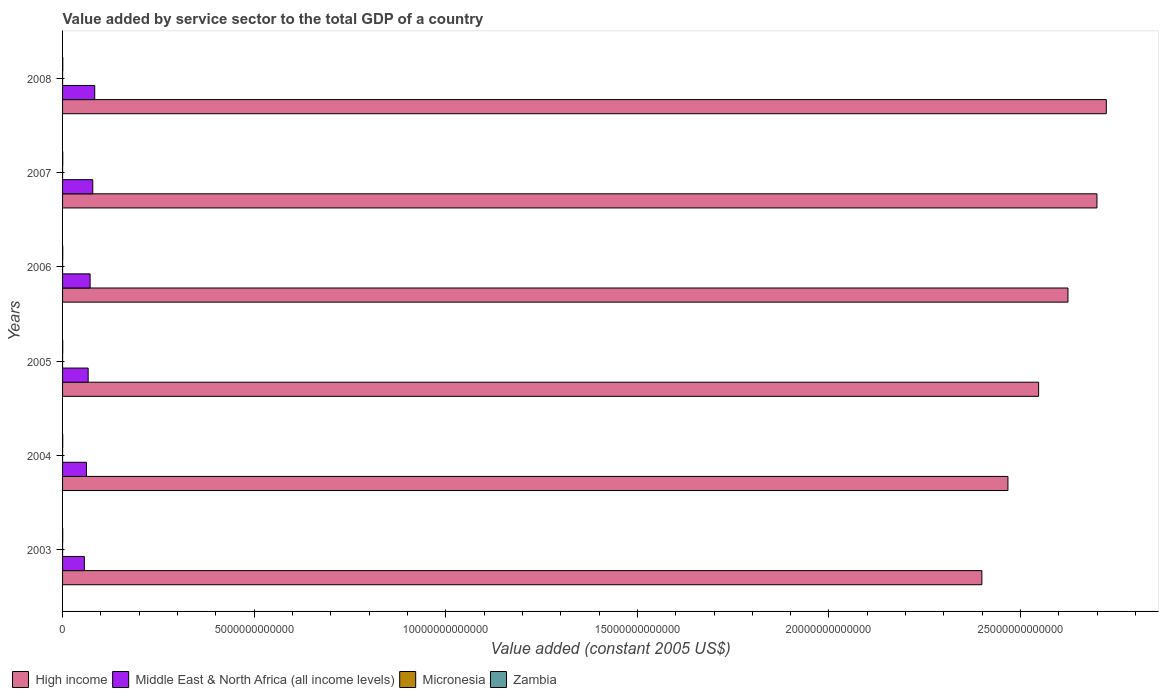How many bars are there on the 4th tick from the top?
Your response must be concise. 4. How many bars are there on the 1st tick from the bottom?
Your answer should be very brief. 4. In how many cases, is the number of bars for a given year not equal to the number of legend labels?
Offer a very short reply. 0. What is the value added by service sector in Micronesia in 2004?
Offer a terse response. 1.59e+08. Across all years, what is the maximum value added by service sector in High income?
Give a very brief answer. 2.72e+13. Across all years, what is the minimum value added by service sector in Zambia?
Your response must be concise. 3.51e+09. In which year was the value added by service sector in High income maximum?
Provide a succinct answer. 2008. What is the total value added by service sector in Middle East & North Africa (all income levels) in the graph?
Keep it short and to the point. 4.21e+12. What is the difference between the value added by service sector in Micronesia in 2005 and that in 2006?
Your answer should be compact. -3.71e+06. What is the difference between the value added by service sector in High income in 2004 and the value added by service sector in Micronesia in 2003?
Provide a succinct answer. 2.47e+13. What is the average value added by service sector in Zambia per year?
Provide a short and direct response. 4.39e+09. In the year 2006, what is the difference between the value added by service sector in Zambia and value added by service sector in Middle East & North Africa (all income levels)?
Your answer should be very brief. -7.14e+11. What is the ratio of the value added by service sector in Zambia in 2006 to that in 2008?
Provide a succinct answer. 0.81. Is the value added by service sector in Micronesia in 2004 less than that in 2007?
Your answer should be very brief. No. What is the difference between the highest and the second highest value added by service sector in Middle East & North Africa (all income levels)?
Give a very brief answer. 5.10e+1. What is the difference between the highest and the lowest value added by service sector in Zambia?
Give a very brief answer. 2.05e+09. Is the sum of the value added by service sector in High income in 2003 and 2008 greater than the maximum value added by service sector in Middle East & North Africa (all income levels) across all years?
Make the answer very short. Yes. Is it the case that in every year, the sum of the value added by service sector in Micronesia and value added by service sector in Middle East & North Africa (all income levels) is greater than the sum of value added by service sector in Zambia and value added by service sector in High income?
Offer a very short reply. No. What does the 4th bar from the top in 2003 represents?
Make the answer very short. High income. What does the 4th bar from the bottom in 2006 represents?
Your response must be concise. Zambia. Is it the case that in every year, the sum of the value added by service sector in High income and value added by service sector in Zambia is greater than the value added by service sector in Micronesia?
Give a very brief answer. Yes. How many bars are there?
Keep it short and to the point. 24. How many years are there in the graph?
Your response must be concise. 6. What is the difference between two consecutive major ticks on the X-axis?
Your response must be concise. 5.00e+12. What is the title of the graph?
Your answer should be compact. Value added by service sector to the total GDP of a country. Does "Timor-Leste" appear as one of the legend labels in the graph?
Offer a very short reply. No. What is the label or title of the X-axis?
Your answer should be compact. Value added (constant 2005 US$). What is the label or title of the Y-axis?
Your answer should be compact. Years. What is the Value added (constant 2005 US$) of High income in 2003?
Give a very brief answer. 2.40e+13. What is the Value added (constant 2005 US$) of Middle East & North Africa (all income levels) in 2003?
Give a very brief answer. 5.69e+11. What is the Value added (constant 2005 US$) of Micronesia in 2003?
Ensure brevity in your answer.  1.61e+08. What is the Value added (constant 2005 US$) in Zambia in 2003?
Provide a succinct answer. 3.51e+09. What is the Value added (constant 2005 US$) in High income in 2004?
Make the answer very short. 2.47e+13. What is the Value added (constant 2005 US$) of Middle East & North Africa (all income levels) in 2004?
Offer a terse response. 6.23e+11. What is the Value added (constant 2005 US$) in Micronesia in 2004?
Offer a terse response. 1.59e+08. What is the Value added (constant 2005 US$) of Zambia in 2004?
Make the answer very short. 3.75e+09. What is the Value added (constant 2005 US$) of High income in 2005?
Provide a succinct answer. 2.55e+13. What is the Value added (constant 2005 US$) in Middle East & North Africa (all income levels) in 2005?
Provide a short and direct response. 6.68e+11. What is the Value added (constant 2005 US$) of Micronesia in 2005?
Keep it short and to the point. 1.60e+08. What is the Value added (constant 2005 US$) in Zambia in 2005?
Offer a very short reply. 4.08e+09. What is the Value added (constant 2005 US$) in High income in 2006?
Offer a terse response. 2.62e+13. What is the Value added (constant 2005 US$) of Middle East & North Africa (all income levels) in 2006?
Ensure brevity in your answer.  7.19e+11. What is the Value added (constant 2005 US$) in Micronesia in 2006?
Offer a very short reply. 1.63e+08. What is the Value added (constant 2005 US$) in Zambia in 2006?
Give a very brief answer. 4.48e+09. What is the Value added (constant 2005 US$) in High income in 2007?
Give a very brief answer. 2.70e+13. What is the Value added (constant 2005 US$) in Middle East & North Africa (all income levels) in 2007?
Offer a very short reply. 7.88e+11. What is the Value added (constant 2005 US$) in Micronesia in 2007?
Your response must be concise. 1.57e+08. What is the Value added (constant 2005 US$) in Zambia in 2007?
Provide a short and direct response. 4.98e+09. What is the Value added (constant 2005 US$) of High income in 2008?
Provide a short and direct response. 2.72e+13. What is the Value added (constant 2005 US$) of Middle East & North Africa (all income levels) in 2008?
Make the answer very short. 8.39e+11. What is the Value added (constant 2005 US$) in Micronesia in 2008?
Give a very brief answer. 1.52e+08. What is the Value added (constant 2005 US$) of Zambia in 2008?
Give a very brief answer. 5.56e+09. Across all years, what is the maximum Value added (constant 2005 US$) in High income?
Give a very brief answer. 2.72e+13. Across all years, what is the maximum Value added (constant 2005 US$) of Middle East & North Africa (all income levels)?
Ensure brevity in your answer.  8.39e+11. Across all years, what is the maximum Value added (constant 2005 US$) in Micronesia?
Ensure brevity in your answer.  1.63e+08. Across all years, what is the maximum Value added (constant 2005 US$) in Zambia?
Your answer should be very brief. 5.56e+09. Across all years, what is the minimum Value added (constant 2005 US$) in High income?
Provide a short and direct response. 2.40e+13. Across all years, what is the minimum Value added (constant 2005 US$) in Middle East & North Africa (all income levels)?
Your answer should be compact. 5.69e+11. Across all years, what is the minimum Value added (constant 2005 US$) in Micronesia?
Provide a short and direct response. 1.52e+08. Across all years, what is the minimum Value added (constant 2005 US$) of Zambia?
Provide a succinct answer. 3.51e+09. What is the total Value added (constant 2005 US$) in High income in the graph?
Your response must be concise. 1.55e+14. What is the total Value added (constant 2005 US$) in Middle East & North Africa (all income levels) in the graph?
Provide a short and direct response. 4.21e+12. What is the total Value added (constant 2005 US$) in Micronesia in the graph?
Provide a short and direct response. 9.52e+08. What is the total Value added (constant 2005 US$) of Zambia in the graph?
Give a very brief answer. 2.64e+1. What is the difference between the Value added (constant 2005 US$) of High income in 2003 and that in 2004?
Provide a short and direct response. -6.80e+11. What is the difference between the Value added (constant 2005 US$) in Middle East & North Africa (all income levels) in 2003 and that in 2004?
Offer a terse response. -5.49e+1. What is the difference between the Value added (constant 2005 US$) of Micronesia in 2003 and that in 2004?
Give a very brief answer. 2.17e+06. What is the difference between the Value added (constant 2005 US$) of Zambia in 2003 and that in 2004?
Provide a succinct answer. -2.35e+08. What is the difference between the Value added (constant 2005 US$) of High income in 2003 and that in 2005?
Give a very brief answer. -1.48e+12. What is the difference between the Value added (constant 2005 US$) in Middle East & North Africa (all income levels) in 2003 and that in 2005?
Your answer should be very brief. -9.94e+1. What is the difference between the Value added (constant 2005 US$) in Micronesia in 2003 and that in 2005?
Give a very brief answer. 1.59e+06. What is the difference between the Value added (constant 2005 US$) in Zambia in 2003 and that in 2005?
Offer a terse response. -5.67e+08. What is the difference between the Value added (constant 2005 US$) of High income in 2003 and that in 2006?
Keep it short and to the point. -2.25e+12. What is the difference between the Value added (constant 2005 US$) of Middle East & North Africa (all income levels) in 2003 and that in 2006?
Provide a succinct answer. -1.50e+11. What is the difference between the Value added (constant 2005 US$) in Micronesia in 2003 and that in 2006?
Keep it short and to the point. -2.11e+06. What is the difference between the Value added (constant 2005 US$) of Zambia in 2003 and that in 2006?
Ensure brevity in your answer.  -9.69e+08. What is the difference between the Value added (constant 2005 US$) of High income in 2003 and that in 2007?
Ensure brevity in your answer.  -3.00e+12. What is the difference between the Value added (constant 2005 US$) of Middle East & North Africa (all income levels) in 2003 and that in 2007?
Your response must be concise. -2.20e+11. What is the difference between the Value added (constant 2005 US$) of Micronesia in 2003 and that in 2007?
Offer a very short reply. 3.76e+06. What is the difference between the Value added (constant 2005 US$) in Zambia in 2003 and that in 2007?
Offer a very short reply. -1.47e+09. What is the difference between the Value added (constant 2005 US$) in High income in 2003 and that in 2008?
Provide a short and direct response. -3.25e+12. What is the difference between the Value added (constant 2005 US$) of Middle East & North Africa (all income levels) in 2003 and that in 2008?
Your response must be concise. -2.71e+11. What is the difference between the Value added (constant 2005 US$) in Micronesia in 2003 and that in 2008?
Your answer should be compact. 9.32e+06. What is the difference between the Value added (constant 2005 US$) in Zambia in 2003 and that in 2008?
Give a very brief answer. -2.05e+09. What is the difference between the Value added (constant 2005 US$) in High income in 2004 and that in 2005?
Make the answer very short. -8.01e+11. What is the difference between the Value added (constant 2005 US$) of Middle East & North Africa (all income levels) in 2004 and that in 2005?
Your answer should be compact. -4.45e+1. What is the difference between the Value added (constant 2005 US$) of Micronesia in 2004 and that in 2005?
Give a very brief answer. -5.77e+05. What is the difference between the Value added (constant 2005 US$) in Zambia in 2004 and that in 2005?
Ensure brevity in your answer.  -3.31e+08. What is the difference between the Value added (constant 2005 US$) in High income in 2004 and that in 2006?
Provide a succinct answer. -1.57e+12. What is the difference between the Value added (constant 2005 US$) in Middle East & North Africa (all income levels) in 2004 and that in 2006?
Offer a terse response. -9.54e+1. What is the difference between the Value added (constant 2005 US$) in Micronesia in 2004 and that in 2006?
Your answer should be very brief. -4.28e+06. What is the difference between the Value added (constant 2005 US$) in Zambia in 2004 and that in 2006?
Provide a short and direct response. -7.34e+08. What is the difference between the Value added (constant 2005 US$) of High income in 2004 and that in 2007?
Offer a very short reply. -2.32e+12. What is the difference between the Value added (constant 2005 US$) in Middle East & North Africa (all income levels) in 2004 and that in 2007?
Ensure brevity in your answer.  -1.65e+11. What is the difference between the Value added (constant 2005 US$) in Micronesia in 2004 and that in 2007?
Offer a very short reply. 1.59e+06. What is the difference between the Value added (constant 2005 US$) of Zambia in 2004 and that in 2007?
Your answer should be compact. -1.23e+09. What is the difference between the Value added (constant 2005 US$) of High income in 2004 and that in 2008?
Provide a short and direct response. -2.57e+12. What is the difference between the Value added (constant 2005 US$) of Middle East & North Africa (all income levels) in 2004 and that in 2008?
Provide a succinct answer. -2.16e+11. What is the difference between the Value added (constant 2005 US$) of Micronesia in 2004 and that in 2008?
Keep it short and to the point. 7.15e+06. What is the difference between the Value added (constant 2005 US$) of Zambia in 2004 and that in 2008?
Your answer should be compact. -1.81e+09. What is the difference between the Value added (constant 2005 US$) in High income in 2005 and that in 2006?
Your answer should be very brief. -7.66e+11. What is the difference between the Value added (constant 2005 US$) in Middle East & North Africa (all income levels) in 2005 and that in 2006?
Offer a terse response. -5.10e+1. What is the difference between the Value added (constant 2005 US$) in Micronesia in 2005 and that in 2006?
Your response must be concise. -3.71e+06. What is the difference between the Value added (constant 2005 US$) of Zambia in 2005 and that in 2006?
Your answer should be compact. -4.02e+08. What is the difference between the Value added (constant 2005 US$) in High income in 2005 and that in 2007?
Keep it short and to the point. -1.52e+12. What is the difference between the Value added (constant 2005 US$) in Middle East & North Africa (all income levels) in 2005 and that in 2007?
Keep it short and to the point. -1.20e+11. What is the difference between the Value added (constant 2005 US$) in Micronesia in 2005 and that in 2007?
Make the answer very short. 2.16e+06. What is the difference between the Value added (constant 2005 US$) in Zambia in 2005 and that in 2007?
Your answer should be very brief. -9.01e+08. What is the difference between the Value added (constant 2005 US$) of High income in 2005 and that in 2008?
Your answer should be compact. -1.77e+12. What is the difference between the Value added (constant 2005 US$) of Middle East & North Africa (all income levels) in 2005 and that in 2008?
Offer a very short reply. -1.71e+11. What is the difference between the Value added (constant 2005 US$) of Micronesia in 2005 and that in 2008?
Provide a short and direct response. 7.72e+06. What is the difference between the Value added (constant 2005 US$) of Zambia in 2005 and that in 2008?
Your answer should be very brief. -1.48e+09. What is the difference between the Value added (constant 2005 US$) in High income in 2006 and that in 2007?
Your response must be concise. -7.56e+11. What is the difference between the Value added (constant 2005 US$) in Middle East & North Africa (all income levels) in 2006 and that in 2007?
Make the answer very short. -6.94e+1. What is the difference between the Value added (constant 2005 US$) in Micronesia in 2006 and that in 2007?
Your response must be concise. 5.87e+06. What is the difference between the Value added (constant 2005 US$) of Zambia in 2006 and that in 2007?
Make the answer very short. -4.98e+08. What is the difference between the Value added (constant 2005 US$) in High income in 2006 and that in 2008?
Keep it short and to the point. -1.00e+12. What is the difference between the Value added (constant 2005 US$) in Middle East & North Africa (all income levels) in 2006 and that in 2008?
Give a very brief answer. -1.20e+11. What is the difference between the Value added (constant 2005 US$) in Micronesia in 2006 and that in 2008?
Offer a very short reply. 1.14e+07. What is the difference between the Value added (constant 2005 US$) of Zambia in 2006 and that in 2008?
Provide a short and direct response. -1.08e+09. What is the difference between the Value added (constant 2005 US$) of High income in 2007 and that in 2008?
Give a very brief answer. -2.44e+11. What is the difference between the Value added (constant 2005 US$) of Middle East & North Africa (all income levels) in 2007 and that in 2008?
Offer a terse response. -5.10e+1. What is the difference between the Value added (constant 2005 US$) of Micronesia in 2007 and that in 2008?
Offer a terse response. 5.56e+06. What is the difference between the Value added (constant 2005 US$) in Zambia in 2007 and that in 2008?
Give a very brief answer. -5.81e+08. What is the difference between the Value added (constant 2005 US$) in High income in 2003 and the Value added (constant 2005 US$) in Middle East & North Africa (all income levels) in 2004?
Keep it short and to the point. 2.34e+13. What is the difference between the Value added (constant 2005 US$) of High income in 2003 and the Value added (constant 2005 US$) of Micronesia in 2004?
Ensure brevity in your answer.  2.40e+13. What is the difference between the Value added (constant 2005 US$) of High income in 2003 and the Value added (constant 2005 US$) of Zambia in 2004?
Keep it short and to the point. 2.40e+13. What is the difference between the Value added (constant 2005 US$) in Middle East & North Africa (all income levels) in 2003 and the Value added (constant 2005 US$) in Micronesia in 2004?
Keep it short and to the point. 5.68e+11. What is the difference between the Value added (constant 2005 US$) in Middle East & North Africa (all income levels) in 2003 and the Value added (constant 2005 US$) in Zambia in 2004?
Provide a succinct answer. 5.65e+11. What is the difference between the Value added (constant 2005 US$) in Micronesia in 2003 and the Value added (constant 2005 US$) in Zambia in 2004?
Provide a succinct answer. -3.59e+09. What is the difference between the Value added (constant 2005 US$) of High income in 2003 and the Value added (constant 2005 US$) of Middle East & North Africa (all income levels) in 2005?
Your answer should be very brief. 2.33e+13. What is the difference between the Value added (constant 2005 US$) of High income in 2003 and the Value added (constant 2005 US$) of Micronesia in 2005?
Your answer should be compact. 2.40e+13. What is the difference between the Value added (constant 2005 US$) of High income in 2003 and the Value added (constant 2005 US$) of Zambia in 2005?
Provide a short and direct response. 2.40e+13. What is the difference between the Value added (constant 2005 US$) in Middle East & North Africa (all income levels) in 2003 and the Value added (constant 2005 US$) in Micronesia in 2005?
Provide a succinct answer. 5.68e+11. What is the difference between the Value added (constant 2005 US$) of Middle East & North Africa (all income levels) in 2003 and the Value added (constant 2005 US$) of Zambia in 2005?
Provide a succinct answer. 5.64e+11. What is the difference between the Value added (constant 2005 US$) of Micronesia in 2003 and the Value added (constant 2005 US$) of Zambia in 2005?
Keep it short and to the point. -3.92e+09. What is the difference between the Value added (constant 2005 US$) of High income in 2003 and the Value added (constant 2005 US$) of Middle East & North Africa (all income levels) in 2006?
Ensure brevity in your answer.  2.33e+13. What is the difference between the Value added (constant 2005 US$) of High income in 2003 and the Value added (constant 2005 US$) of Micronesia in 2006?
Ensure brevity in your answer.  2.40e+13. What is the difference between the Value added (constant 2005 US$) in High income in 2003 and the Value added (constant 2005 US$) in Zambia in 2006?
Your response must be concise. 2.40e+13. What is the difference between the Value added (constant 2005 US$) of Middle East & North Africa (all income levels) in 2003 and the Value added (constant 2005 US$) of Micronesia in 2006?
Your response must be concise. 5.68e+11. What is the difference between the Value added (constant 2005 US$) in Middle East & North Africa (all income levels) in 2003 and the Value added (constant 2005 US$) in Zambia in 2006?
Offer a very short reply. 5.64e+11. What is the difference between the Value added (constant 2005 US$) of Micronesia in 2003 and the Value added (constant 2005 US$) of Zambia in 2006?
Your response must be concise. -4.32e+09. What is the difference between the Value added (constant 2005 US$) of High income in 2003 and the Value added (constant 2005 US$) of Middle East & North Africa (all income levels) in 2007?
Ensure brevity in your answer.  2.32e+13. What is the difference between the Value added (constant 2005 US$) of High income in 2003 and the Value added (constant 2005 US$) of Micronesia in 2007?
Provide a short and direct response. 2.40e+13. What is the difference between the Value added (constant 2005 US$) of High income in 2003 and the Value added (constant 2005 US$) of Zambia in 2007?
Your response must be concise. 2.40e+13. What is the difference between the Value added (constant 2005 US$) of Middle East & North Africa (all income levels) in 2003 and the Value added (constant 2005 US$) of Micronesia in 2007?
Offer a terse response. 5.68e+11. What is the difference between the Value added (constant 2005 US$) in Middle East & North Africa (all income levels) in 2003 and the Value added (constant 2005 US$) in Zambia in 2007?
Keep it short and to the point. 5.64e+11. What is the difference between the Value added (constant 2005 US$) of Micronesia in 2003 and the Value added (constant 2005 US$) of Zambia in 2007?
Keep it short and to the point. -4.82e+09. What is the difference between the Value added (constant 2005 US$) in High income in 2003 and the Value added (constant 2005 US$) in Middle East & North Africa (all income levels) in 2008?
Offer a terse response. 2.32e+13. What is the difference between the Value added (constant 2005 US$) of High income in 2003 and the Value added (constant 2005 US$) of Micronesia in 2008?
Your response must be concise. 2.40e+13. What is the difference between the Value added (constant 2005 US$) of High income in 2003 and the Value added (constant 2005 US$) of Zambia in 2008?
Offer a terse response. 2.40e+13. What is the difference between the Value added (constant 2005 US$) in Middle East & North Africa (all income levels) in 2003 and the Value added (constant 2005 US$) in Micronesia in 2008?
Offer a terse response. 5.68e+11. What is the difference between the Value added (constant 2005 US$) of Middle East & North Africa (all income levels) in 2003 and the Value added (constant 2005 US$) of Zambia in 2008?
Your response must be concise. 5.63e+11. What is the difference between the Value added (constant 2005 US$) of Micronesia in 2003 and the Value added (constant 2005 US$) of Zambia in 2008?
Your answer should be compact. -5.40e+09. What is the difference between the Value added (constant 2005 US$) in High income in 2004 and the Value added (constant 2005 US$) in Middle East & North Africa (all income levels) in 2005?
Provide a succinct answer. 2.40e+13. What is the difference between the Value added (constant 2005 US$) in High income in 2004 and the Value added (constant 2005 US$) in Micronesia in 2005?
Your answer should be compact. 2.47e+13. What is the difference between the Value added (constant 2005 US$) of High income in 2004 and the Value added (constant 2005 US$) of Zambia in 2005?
Provide a succinct answer. 2.47e+13. What is the difference between the Value added (constant 2005 US$) of Middle East & North Africa (all income levels) in 2004 and the Value added (constant 2005 US$) of Micronesia in 2005?
Keep it short and to the point. 6.23e+11. What is the difference between the Value added (constant 2005 US$) in Middle East & North Africa (all income levels) in 2004 and the Value added (constant 2005 US$) in Zambia in 2005?
Offer a very short reply. 6.19e+11. What is the difference between the Value added (constant 2005 US$) in Micronesia in 2004 and the Value added (constant 2005 US$) in Zambia in 2005?
Ensure brevity in your answer.  -3.92e+09. What is the difference between the Value added (constant 2005 US$) of High income in 2004 and the Value added (constant 2005 US$) of Middle East & North Africa (all income levels) in 2006?
Give a very brief answer. 2.40e+13. What is the difference between the Value added (constant 2005 US$) of High income in 2004 and the Value added (constant 2005 US$) of Micronesia in 2006?
Offer a terse response. 2.47e+13. What is the difference between the Value added (constant 2005 US$) in High income in 2004 and the Value added (constant 2005 US$) in Zambia in 2006?
Make the answer very short. 2.47e+13. What is the difference between the Value added (constant 2005 US$) of Middle East & North Africa (all income levels) in 2004 and the Value added (constant 2005 US$) of Micronesia in 2006?
Make the answer very short. 6.23e+11. What is the difference between the Value added (constant 2005 US$) in Middle East & North Africa (all income levels) in 2004 and the Value added (constant 2005 US$) in Zambia in 2006?
Your response must be concise. 6.19e+11. What is the difference between the Value added (constant 2005 US$) in Micronesia in 2004 and the Value added (constant 2005 US$) in Zambia in 2006?
Your answer should be very brief. -4.32e+09. What is the difference between the Value added (constant 2005 US$) of High income in 2004 and the Value added (constant 2005 US$) of Middle East & North Africa (all income levels) in 2007?
Give a very brief answer. 2.39e+13. What is the difference between the Value added (constant 2005 US$) in High income in 2004 and the Value added (constant 2005 US$) in Micronesia in 2007?
Give a very brief answer. 2.47e+13. What is the difference between the Value added (constant 2005 US$) in High income in 2004 and the Value added (constant 2005 US$) in Zambia in 2007?
Keep it short and to the point. 2.47e+13. What is the difference between the Value added (constant 2005 US$) of Middle East & North Africa (all income levels) in 2004 and the Value added (constant 2005 US$) of Micronesia in 2007?
Your answer should be very brief. 6.23e+11. What is the difference between the Value added (constant 2005 US$) in Middle East & North Africa (all income levels) in 2004 and the Value added (constant 2005 US$) in Zambia in 2007?
Your answer should be compact. 6.18e+11. What is the difference between the Value added (constant 2005 US$) of Micronesia in 2004 and the Value added (constant 2005 US$) of Zambia in 2007?
Provide a short and direct response. -4.82e+09. What is the difference between the Value added (constant 2005 US$) in High income in 2004 and the Value added (constant 2005 US$) in Middle East & North Africa (all income levels) in 2008?
Offer a terse response. 2.38e+13. What is the difference between the Value added (constant 2005 US$) in High income in 2004 and the Value added (constant 2005 US$) in Micronesia in 2008?
Provide a short and direct response. 2.47e+13. What is the difference between the Value added (constant 2005 US$) of High income in 2004 and the Value added (constant 2005 US$) of Zambia in 2008?
Offer a very short reply. 2.47e+13. What is the difference between the Value added (constant 2005 US$) in Middle East & North Africa (all income levels) in 2004 and the Value added (constant 2005 US$) in Micronesia in 2008?
Keep it short and to the point. 6.23e+11. What is the difference between the Value added (constant 2005 US$) in Middle East & North Africa (all income levels) in 2004 and the Value added (constant 2005 US$) in Zambia in 2008?
Your answer should be very brief. 6.18e+11. What is the difference between the Value added (constant 2005 US$) of Micronesia in 2004 and the Value added (constant 2005 US$) of Zambia in 2008?
Your response must be concise. -5.40e+09. What is the difference between the Value added (constant 2005 US$) in High income in 2005 and the Value added (constant 2005 US$) in Middle East & North Africa (all income levels) in 2006?
Offer a terse response. 2.48e+13. What is the difference between the Value added (constant 2005 US$) in High income in 2005 and the Value added (constant 2005 US$) in Micronesia in 2006?
Your answer should be compact. 2.55e+13. What is the difference between the Value added (constant 2005 US$) in High income in 2005 and the Value added (constant 2005 US$) in Zambia in 2006?
Your response must be concise. 2.55e+13. What is the difference between the Value added (constant 2005 US$) in Middle East & North Africa (all income levels) in 2005 and the Value added (constant 2005 US$) in Micronesia in 2006?
Your answer should be compact. 6.68e+11. What is the difference between the Value added (constant 2005 US$) of Middle East & North Africa (all income levels) in 2005 and the Value added (constant 2005 US$) of Zambia in 2006?
Your answer should be very brief. 6.63e+11. What is the difference between the Value added (constant 2005 US$) in Micronesia in 2005 and the Value added (constant 2005 US$) in Zambia in 2006?
Provide a succinct answer. -4.32e+09. What is the difference between the Value added (constant 2005 US$) of High income in 2005 and the Value added (constant 2005 US$) of Middle East & North Africa (all income levels) in 2007?
Keep it short and to the point. 2.47e+13. What is the difference between the Value added (constant 2005 US$) of High income in 2005 and the Value added (constant 2005 US$) of Micronesia in 2007?
Your answer should be compact. 2.55e+13. What is the difference between the Value added (constant 2005 US$) in High income in 2005 and the Value added (constant 2005 US$) in Zambia in 2007?
Ensure brevity in your answer.  2.55e+13. What is the difference between the Value added (constant 2005 US$) in Middle East & North Africa (all income levels) in 2005 and the Value added (constant 2005 US$) in Micronesia in 2007?
Make the answer very short. 6.68e+11. What is the difference between the Value added (constant 2005 US$) in Middle East & North Africa (all income levels) in 2005 and the Value added (constant 2005 US$) in Zambia in 2007?
Provide a succinct answer. 6.63e+11. What is the difference between the Value added (constant 2005 US$) in Micronesia in 2005 and the Value added (constant 2005 US$) in Zambia in 2007?
Ensure brevity in your answer.  -4.82e+09. What is the difference between the Value added (constant 2005 US$) of High income in 2005 and the Value added (constant 2005 US$) of Middle East & North Africa (all income levels) in 2008?
Keep it short and to the point. 2.46e+13. What is the difference between the Value added (constant 2005 US$) of High income in 2005 and the Value added (constant 2005 US$) of Micronesia in 2008?
Ensure brevity in your answer.  2.55e+13. What is the difference between the Value added (constant 2005 US$) of High income in 2005 and the Value added (constant 2005 US$) of Zambia in 2008?
Provide a short and direct response. 2.55e+13. What is the difference between the Value added (constant 2005 US$) in Middle East & North Africa (all income levels) in 2005 and the Value added (constant 2005 US$) in Micronesia in 2008?
Provide a succinct answer. 6.68e+11. What is the difference between the Value added (constant 2005 US$) in Middle East & North Africa (all income levels) in 2005 and the Value added (constant 2005 US$) in Zambia in 2008?
Ensure brevity in your answer.  6.62e+11. What is the difference between the Value added (constant 2005 US$) of Micronesia in 2005 and the Value added (constant 2005 US$) of Zambia in 2008?
Provide a succinct answer. -5.40e+09. What is the difference between the Value added (constant 2005 US$) in High income in 2006 and the Value added (constant 2005 US$) in Middle East & North Africa (all income levels) in 2007?
Your response must be concise. 2.54e+13. What is the difference between the Value added (constant 2005 US$) of High income in 2006 and the Value added (constant 2005 US$) of Micronesia in 2007?
Your answer should be compact. 2.62e+13. What is the difference between the Value added (constant 2005 US$) of High income in 2006 and the Value added (constant 2005 US$) of Zambia in 2007?
Provide a succinct answer. 2.62e+13. What is the difference between the Value added (constant 2005 US$) in Middle East & North Africa (all income levels) in 2006 and the Value added (constant 2005 US$) in Micronesia in 2007?
Your response must be concise. 7.19e+11. What is the difference between the Value added (constant 2005 US$) in Middle East & North Africa (all income levels) in 2006 and the Value added (constant 2005 US$) in Zambia in 2007?
Your answer should be very brief. 7.14e+11. What is the difference between the Value added (constant 2005 US$) of Micronesia in 2006 and the Value added (constant 2005 US$) of Zambia in 2007?
Offer a very short reply. -4.82e+09. What is the difference between the Value added (constant 2005 US$) of High income in 2006 and the Value added (constant 2005 US$) of Middle East & North Africa (all income levels) in 2008?
Provide a succinct answer. 2.54e+13. What is the difference between the Value added (constant 2005 US$) in High income in 2006 and the Value added (constant 2005 US$) in Micronesia in 2008?
Your response must be concise. 2.62e+13. What is the difference between the Value added (constant 2005 US$) in High income in 2006 and the Value added (constant 2005 US$) in Zambia in 2008?
Your answer should be compact. 2.62e+13. What is the difference between the Value added (constant 2005 US$) in Middle East & North Africa (all income levels) in 2006 and the Value added (constant 2005 US$) in Micronesia in 2008?
Provide a short and direct response. 7.19e+11. What is the difference between the Value added (constant 2005 US$) of Middle East & North Africa (all income levels) in 2006 and the Value added (constant 2005 US$) of Zambia in 2008?
Keep it short and to the point. 7.13e+11. What is the difference between the Value added (constant 2005 US$) of Micronesia in 2006 and the Value added (constant 2005 US$) of Zambia in 2008?
Keep it short and to the point. -5.40e+09. What is the difference between the Value added (constant 2005 US$) of High income in 2007 and the Value added (constant 2005 US$) of Middle East & North Africa (all income levels) in 2008?
Provide a succinct answer. 2.62e+13. What is the difference between the Value added (constant 2005 US$) in High income in 2007 and the Value added (constant 2005 US$) in Micronesia in 2008?
Your answer should be compact. 2.70e+13. What is the difference between the Value added (constant 2005 US$) of High income in 2007 and the Value added (constant 2005 US$) of Zambia in 2008?
Offer a very short reply. 2.70e+13. What is the difference between the Value added (constant 2005 US$) in Middle East & North Africa (all income levels) in 2007 and the Value added (constant 2005 US$) in Micronesia in 2008?
Provide a short and direct response. 7.88e+11. What is the difference between the Value added (constant 2005 US$) in Middle East & North Africa (all income levels) in 2007 and the Value added (constant 2005 US$) in Zambia in 2008?
Give a very brief answer. 7.83e+11. What is the difference between the Value added (constant 2005 US$) of Micronesia in 2007 and the Value added (constant 2005 US$) of Zambia in 2008?
Provide a succinct answer. -5.40e+09. What is the average Value added (constant 2005 US$) in High income per year?
Offer a very short reply. 2.58e+13. What is the average Value added (constant 2005 US$) of Middle East & North Africa (all income levels) per year?
Make the answer very short. 7.01e+11. What is the average Value added (constant 2005 US$) of Micronesia per year?
Keep it short and to the point. 1.59e+08. What is the average Value added (constant 2005 US$) in Zambia per year?
Your response must be concise. 4.39e+09. In the year 2003, what is the difference between the Value added (constant 2005 US$) in High income and Value added (constant 2005 US$) in Middle East & North Africa (all income levels)?
Your answer should be very brief. 2.34e+13. In the year 2003, what is the difference between the Value added (constant 2005 US$) in High income and Value added (constant 2005 US$) in Micronesia?
Ensure brevity in your answer.  2.40e+13. In the year 2003, what is the difference between the Value added (constant 2005 US$) of High income and Value added (constant 2005 US$) of Zambia?
Your answer should be very brief. 2.40e+13. In the year 2003, what is the difference between the Value added (constant 2005 US$) of Middle East & North Africa (all income levels) and Value added (constant 2005 US$) of Micronesia?
Keep it short and to the point. 5.68e+11. In the year 2003, what is the difference between the Value added (constant 2005 US$) in Middle East & North Africa (all income levels) and Value added (constant 2005 US$) in Zambia?
Offer a very short reply. 5.65e+11. In the year 2003, what is the difference between the Value added (constant 2005 US$) in Micronesia and Value added (constant 2005 US$) in Zambia?
Provide a short and direct response. -3.35e+09. In the year 2004, what is the difference between the Value added (constant 2005 US$) in High income and Value added (constant 2005 US$) in Middle East & North Africa (all income levels)?
Make the answer very short. 2.40e+13. In the year 2004, what is the difference between the Value added (constant 2005 US$) of High income and Value added (constant 2005 US$) of Micronesia?
Offer a terse response. 2.47e+13. In the year 2004, what is the difference between the Value added (constant 2005 US$) in High income and Value added (constant 2005 US$) in Zambia?
Your response must be concise. 2.47e+13. In the year 2004, what is the difference between the Value added (constant 2005 US$) of Middle East & North Africa (all income levels) and Value added (constant 2005 US$) of Micronesia?
Your response must be concise. 6.23e+11. In the year 2004, what is the difference between the Value added (constant 2005 US$) in Middle East & North Africa (all income levels) and Value added (constant 2005 US$) in Zambia?
Provide a short and direct response. 6.20e+11. In the year 2004, what is the difference between the Value added (constant 2005 US$) of Micronesia and Value added (constant 2005 US$) of Zambia?
Ensure brevity in your answer.  -3.59e+09. In the year 2005, what is the difference between the Value added (constant 2005 US$) of High income and Value added (constant 2005 US$) of Middle East & North Africa (all income levels)?
Keep it short and to the point. 2.48e+13. In the year 2005, what is the difference between the Value added (constant 2005 US$) in High income and Value added (constant 2005 US$) in Micronesia?
Keep it short and to the point. 2.55e+13. In the year 2005, what is the difference between the Value added (constant 2005 US$) of High income and Value added (constant 2005 US$) of Zambia?
Offer a terse response. 2.55e+13. In the year 2005, what is the difference between the Value added (constant 2005 US$) in Middle East & North Africa (all income levels) and Value added (constant 2005 US$) in Micronesia?
Offer a terse response. 6.68e+11. In the year 2005, what is the difference between the Value added (constant 2005 US$) of Middle East & North Africa (all income levels) and Value added (constant 2005 US$) of Zambia?
Offer a terse response. 6.64e+11. In the year 2005, what is the difference between the Value added (constant 2005 US$) of Micronesia and Value added (constant 2005 US$) of Zambia?
Your answer should be very brief. -3.92e+09. In the year 2006, what is the difference between the Value added (constant 2005 US$) of High income and Value added (constant 2005 US$) of Middle East & North Africa (all income levels)?
Provide a short and direct response. 2.55e+13. In the year 2006, what is the difference between the Value added (constant 2005 US$) in High income and Value added (constant 2005 US$) in Micronesia?
Your response must be concise. 2.62e+13. In the year 2006, what is the difference between the Value added (constant 2005 US$) of High income and Value added (constant 2005 US$) of Zambia?
Your answer should be compact. 2.62e+13. In the year 2006, what is the difference between the Value added (constant 2005 US$) of Middle East & North Africa (all income levels) and Value added (constant 2005 US$) of Micronesia?
Make the answer very short. 7.19e+11. In the year 2006, what is the difference between the Value added (constant 2005 US$) of Middle East & North Africa (all income levels) and Value added (constant 2005 US$) of Zambia?
Give a very brief answer. 7.14e+11. In the year 2006, what is the difference between the Value added (constant 2005 US$) in Micronesia and Value added (constant 2005 US$) in Zambia?
Your answer should be very brief. -4.32e+09. In the year 2007, what is the difference between the Value added (constant 2005 US$) in High income and Value added (constant 2005 US$) in Middle East & North Africa (all income levels)?
Provide a succinct answer. 2.62e+13. In the year 2007, what is the difference between the Value added (constant 2005 US$) in High income and Value added (constant 2005 US$) in Micronesia?
Make the answer very short. 2.70e+13. In the year 2007, what is the difference between the Value added (constant 2005 US$) of High income and Value added (constant 2005 US$) of Zambia?
Your response must be concise. 2.70e+13. In the year 2007, what is the difference between the Value added (constant 2005 US$) in Middle East & North Africa (all income levels) and Value added (constant 2005 US$) in Micronesia?
Ensure brevity in your answer.  7.88e+11. In the year 2007, what is the difference between the Value added (constant 2005 US$) of Middle East & North Africa (all income levels) and Value added (constant 2005 US$) of Zambia?
Your response must be concise. 7.83e+11. In the year 2007, what is the difference between the Value added (constant 2005 US$) in Micronesia and Value added (constant 2005 US$) in Zambia?
Your answer should be very brief. -4.82e+09. In the year 2008, what is the difference between the Value added (constant 2005 US$) of High income and Value added (constant 2005 US$) of Middle East & North Africa (all income levels)?
Offer a terse response. 2.64e+13. In the year 2008, what is the difference between the Value added (constant 2005 US$) of High income and Value added (constant 2005 US$) of Micronesia?
Ensure brevity in your answer.  2.72e+13. In the year 2008, what is the difference between the Value added (constant 2005 US$) of High income and Value added (constant 2005 US$) of Zambia?
Give a very brief answer. 2.72e+13. In the year 2008, what is the difference between the Value added (constant 2005 US$) of Middle East & North Africa (all income levels) and Value added (constant 2005 US$) of Micronesia?
Your answer should be compact. 8.39e+11. In the year 2008, what is the difference between the Value added (constant 2005 US$) in Middle East & North Africa (all income levels) and Value added (constant 2005 US$) in Zambia?
Ensure brevity in your answer.  8.34e+11. In the year 2008, what is the difference between the Value added (constant 2005 US$) in Micronesia and Value added (constant 2005 US$) in Zambia?
Your response must be concise. -5.41e+09. What is the ratio of the Value added (constant 2005 US$) of High income in 2003 to that in 2004?
Provide a succinct answer. 0.97. What is the ratio of the Value added (constant 2005 US$) of Middle East & North Africa (all income levels) in 2003 to that in 2004?
Your answer should be very brief. 0.91. What is the ratio of the Value added (constant 2005 US$) of Micronesia in 2003 to that in 2004?
Offer a terse response. 1.01. What is the ratio of the Value added (constant 2005 US$) of Zambia in 2003 to that in 2004?
Your answer should be compact. 0.94. What is the ratio of the Value added (constant 2005 US$) of High income in 2003 to that in 2005?
Your response must be concise. 0.94. What is the ratio of the Value added (constant 2005 US$) in Middle East & North Africa (all income levels) in 2003 to that in 2005?
Make the answer very short. 0.85. What is the ratio of the Value added (constant 2005 US$) of Micronesia in 2003 to that in 2005?
Provide a succinct answer. 1.01. What is the ratio of the Value added (constant 2005 US$) in Zambia in 2003 to that in 2005?
Offer a very short reply. 0.86. What is the ratio of the Value added (constant 2005 US$) in High income in 2003 to that in 2006?
Keep it short and to the point. 0.91. What is the ratio of the Value added (constant 2005 US$) in Middle East & North Africa (all income levels) in 2003 to that in 2006?
Make the answer very short. 0.79. What is the ratio of the Value added (constant 2005 US$) of Micronesia in 2003 to that in 2006?
Your answer should be compact. 0.99. What is the ratio of the Value added (constant 2005 US$) of Zambia in 2003 to that in 2006?
Give a very brief answer. 0.78. What is the ratio of the Value added (constant 2005 US$) in High income in 2003 to that in 2007?
Make the answer very short. 0.89. What is the ratio of the Value added (constant 2005 US$) in Middle East & North Africa (all income levels) in 2003 to that in 2007?
Provide a short and direct response. 0.72. What is the ratio of the Value added (constant 2005 US$) in Micronesia in 2003 to that in 2007?
Keep it short and to the point. 1.02. What is the ratio of the Value added (constant 2005 US$) of Zambia in 2003 to that in 2007?
Your answer should be very brief. 0.71. What is the ratio of the Value added (constant 2005 US$) of High income in 2003 to that in 2008?
Your answer should be compact. 0.88. What is the ratio of the Value added (constant 2005 US$) in Middle East & North Africa (all income levels) in 2003 to that in 2008?
Your response must be concise. 0.68. What is the ratio of the Value added (constant 2005 US$) in Micronesia in 2003 to that in 2008?
Offer a terse response. 1.06. What is the ratio of the Value added (constant 2005 US$) of Zambia in 2003 to that in 2008?
Ensure brevity in your answer.  0.63. What is the ratio of the Value added (constant 2005 US$) of High income in 2004 to that in 2005?
Your answer should be compact. 0.97. What is the ratio of the Value added (constant 2005 US$) in Middle East & North Africa (all income levels) in 2004 to that in 2005?
Give a very brief answer. 0.93. What is the ratio of the Value added (constant 2005 US$) in Zambia in 2004 to that in 2005?
Provide a short and direct response. 0.92. What is the ratio of the Value added (constant 2005 US$) of High income in 2004 to that in 2006?
Your response must be concise. 0.94. What is the ratio of the Value added (constant 2005 US$) of Middle East & North Africa (all income levels) in 2004 to that in 2006?
Ensure brevity in your answer.  0.87. What is the ratio of the Value added (constant 2005 US$) of Micronesia in 2004 to that in 2006?
Your response must be concise. 0.97. What is the ratio of the Value added (constant 2005 US$) in Zambia in 2004 to that in 2006?
Keep it short and to the point. 0.84. What is the ratio of the Value added (constant 2005 US$) of High income in 2004 to that in 2007?
Your answer should be very brief. 0.91. What is the ratio of the Value added (constant 2005 US$) in Middle East & North Africa (all income levels) in 2004 to that in 2007?
Provide a short and direct response. 0.79. What is the ratio of the Value added (constant 2005 US$) in Micronesia in 2004 to that in 2007?
Your answer should be compact. 1.01. What is the ratio of the Value added (constant 2005 US$) in Zambia in 2004 to that in 2007?
Offer a very short reply. 0.75. What is the ratio of the Value added (constant 2005 US$) of High income in 2004 to that in 2008?
Your answer should be very brief. 0.91. What is the ratio of the Value added (constant 2005 US$) of Middle East & North Africa (all income levels) in 2004 to that in 2008?
Make the answer very short. 0.74. What is the ratio of the Value added (constant 2005 US$) of Micronesia in 2004 to that in 2008?
Offer a terse response. 1.05. What is the ratio of the Value added (constant 2005 US$) of Zambia in 2004 to that in 2008?
Your answer should be compact. 0.67. What is the ratio of the Value added (constant 2005 US$) of High income in 2005 to that in 2006?
Provide a short and direct response. 0.97. What is the ratio of the Value added (constant 2005 US$) in Middle East & North Africa (all income levels) in 2005 to that in 2006?
Your answer should be compact. 0.93. What is the ratio of the Value added (constant 2005 US$) of Micronesia in 2005 to that in 2006?
Offer a very short reply. 0.98. What is the ratio of the Value added (constant 2005 US$) in Zambia in 2005 to that in 2006?
Offer a very short reply. 0.91. What is the ratio of the Value added (constant 2005 US$) in High income in 2005 to that in 2007?
Offer a terse response. 0.94. What is the ratio of the Value added (constant 2005 US$) of Middle East & North Africa (all income levels) in 2005 to that in 2007?
Give a very brief answer. 0.85. What is the ratio of the Value added (constant 2005 US$) in Micronesia in 2005 to that in 2007?
Your answer should be very brief. 1.01. What is the ratio of the Value added (constant 2005 US$) in Zambia in 2005 to that in 2007?
Provide a succinct answer. 0.82. What is the ratio of the Value added (constant 2005 US$) in High income in 2005 to that in 2008?
Keep it short and to the point. 0.94. What is the ratio of the Value added (constant 2005 US$) in Middle East & North Africa (all income levels) in 2005 to that in 2008?
Offer a terse response. 0.8. What is the ratio of the Value added (constant 2005 US$) in Micronesia in 2005 to that in 2008?
Your answer should be very brief. 1.05. What is the ratio of the Value added (constant 2005 US$) in Zambia in 2005 to that in 2008?
Keep it short and to the point. 0.73. What is the ratio of the Value added (constant 2005 US$) of High income in 2006 to that in 2007?
Provide a succinct answer. 0.97. What is the ratio of the Value added (constant 2005 US$) of Middle East & North Africa (all income levels) in 2006 to that in 2007?
Provide a short and direct response. 0.91. What is the ratio of the Value added (constant 2005 US$) of Micronesia in 2006 to that in 2007?
Make the answer very short. 1.04. What is the ratio of the Value added (constant 2005 US$) of Zambia in 2006 to that in 2007?
Give a very brief answer. 0.9. What is the ratio of the Value added (constant 2005 US$) of High income in 2006 to that in 2008?
Make the answer very short. 0.96. What is the ratio of the Value added (constant 2005 US$) of Middle East & North Africa (all income levels) in 2006 to that in 2008?
Your response must be concise. 0.86. What is the ratio of the Value added (constant 2005 US$) in Micronesia in 2006 to that in 2008?
Your answer should be very brief. 1.08. What is the ratio of the Value added (constant 2005 US$) of Zambia in 2006 to that in 2008?
Offer a terse response. 0.81. What is the ratio of the Value added (constant 2005 US$) in High income in 2007 to that in 2008?
Make the answer very short. 0.99. What is the ratio of the Value added (constant 2005 US$) in Middle East & North Africa (all income levels) in 2007 to that in 2008?
Offer a very short reply. 0.94. What is the ratio of the Value added (constant 2005 US$) of Micronesia in 2007 to that in 2008?
Your response must be concise. 1.04. What is the ratio of the Value added (constant 2005 US$) in Zambia in 2007 to that in 2008?
Make the answer very short. 0.9. What is the difference between the highest and the second highest Value added (constant 2005 US$) of High income?
Make the answer very short. 2.44e+11. What is the difference between the highest and the second highest Value added (constant 2005 US$) of Middle East & North Africa (all income levels)?
Give a very brief answer. 5.10e+1. What is the difference between the highest and the second highest Value added (constant 2005 US$) in Micronesia?
Your response must be concise. 2.11e+06. What is the difference between the highest and the second highest Value added (constant 2005 US$) in Zambia?
Make the answer very short. 5.81e+08. What is the difference between the highest and the lowest Value added (constant 2005 US$) of High income?
Offer a very short reply. 3.25e+12. What is the difference between the highest and the lowest Value added (constant 2005 US$) of Middle East & North Africa (all income levels)?
Provide a short and direct response. 2.71e+11. What is the difference between the highest and the lowest Value added (constant 2005 US$) in Micronesia?
Your response must be concise. 1.14e+07. What is the difference between the highest and the lowest Value added (constant 2005 US$) in Zambia?
Keep it short and to the point. 2.05e+09. 